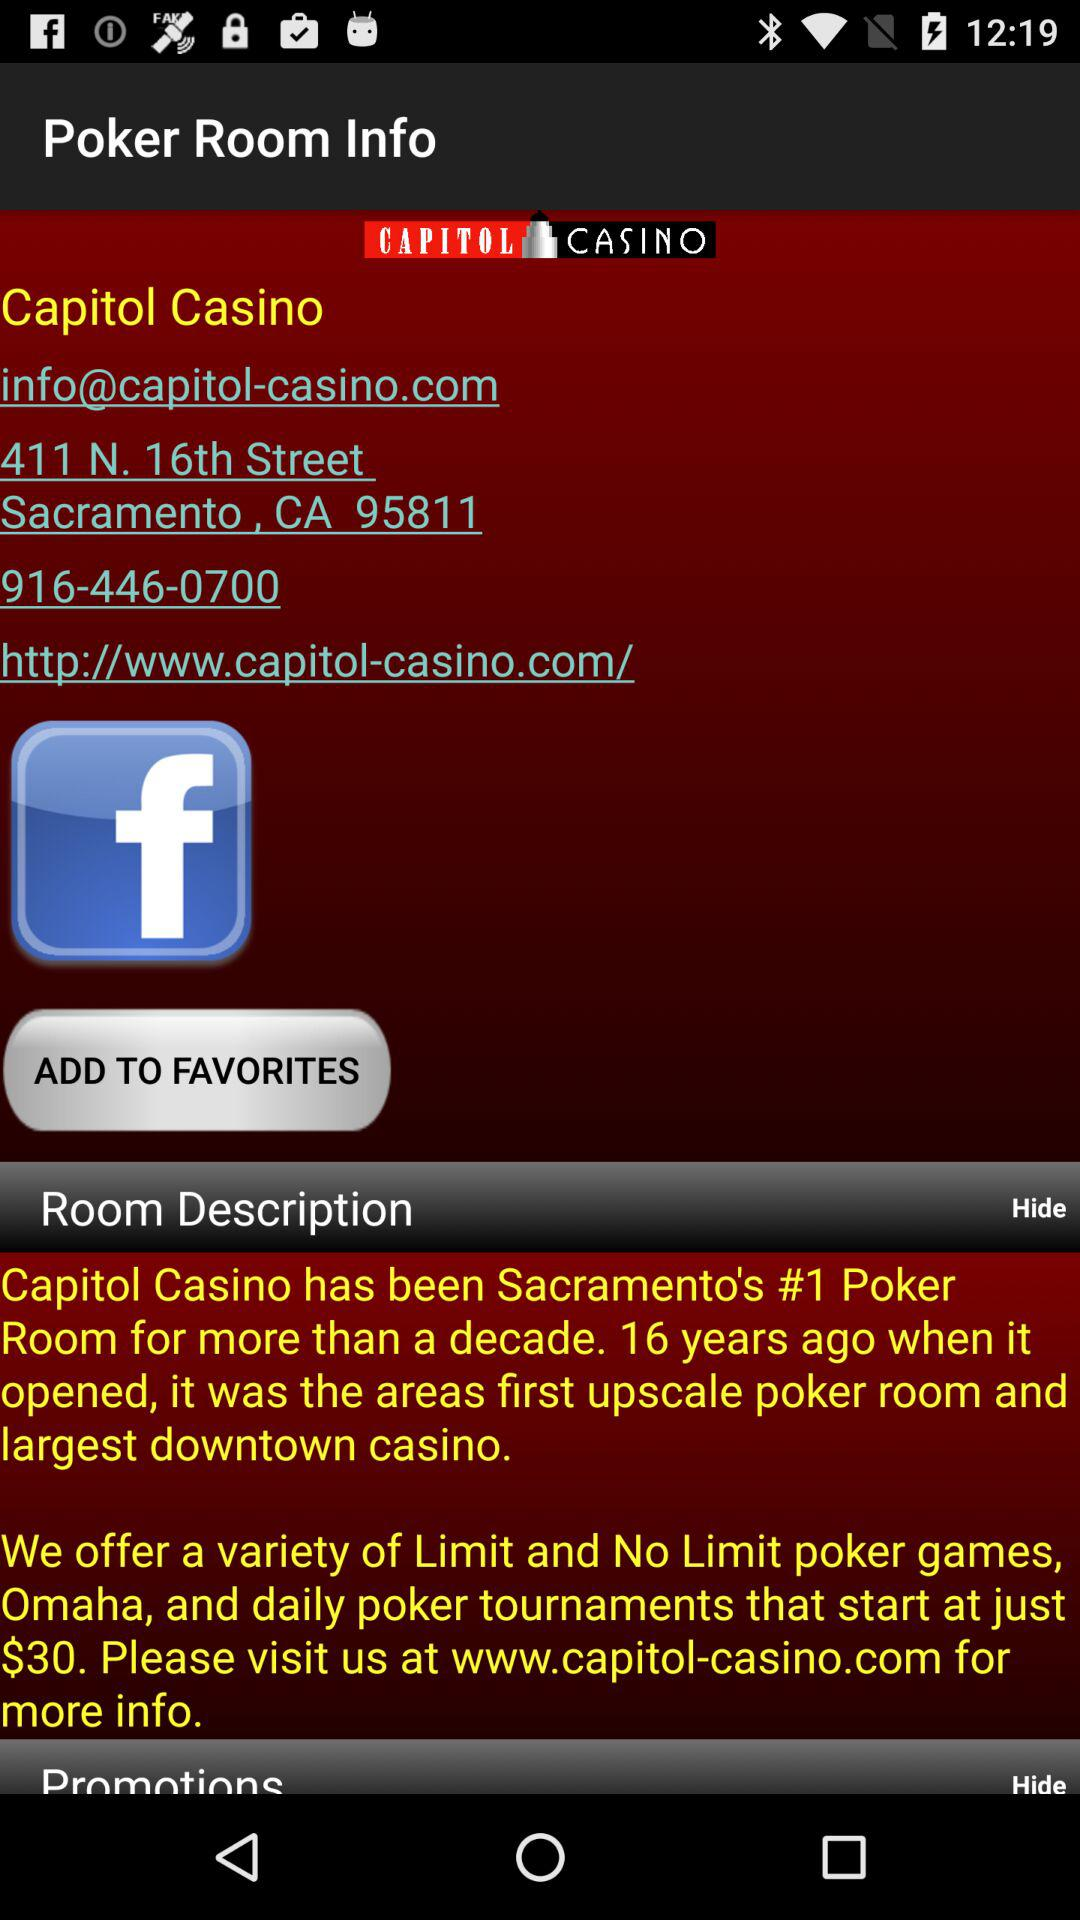Which information is given?
When the provided information is insufficient, respond with <no answer>. <no answer> 